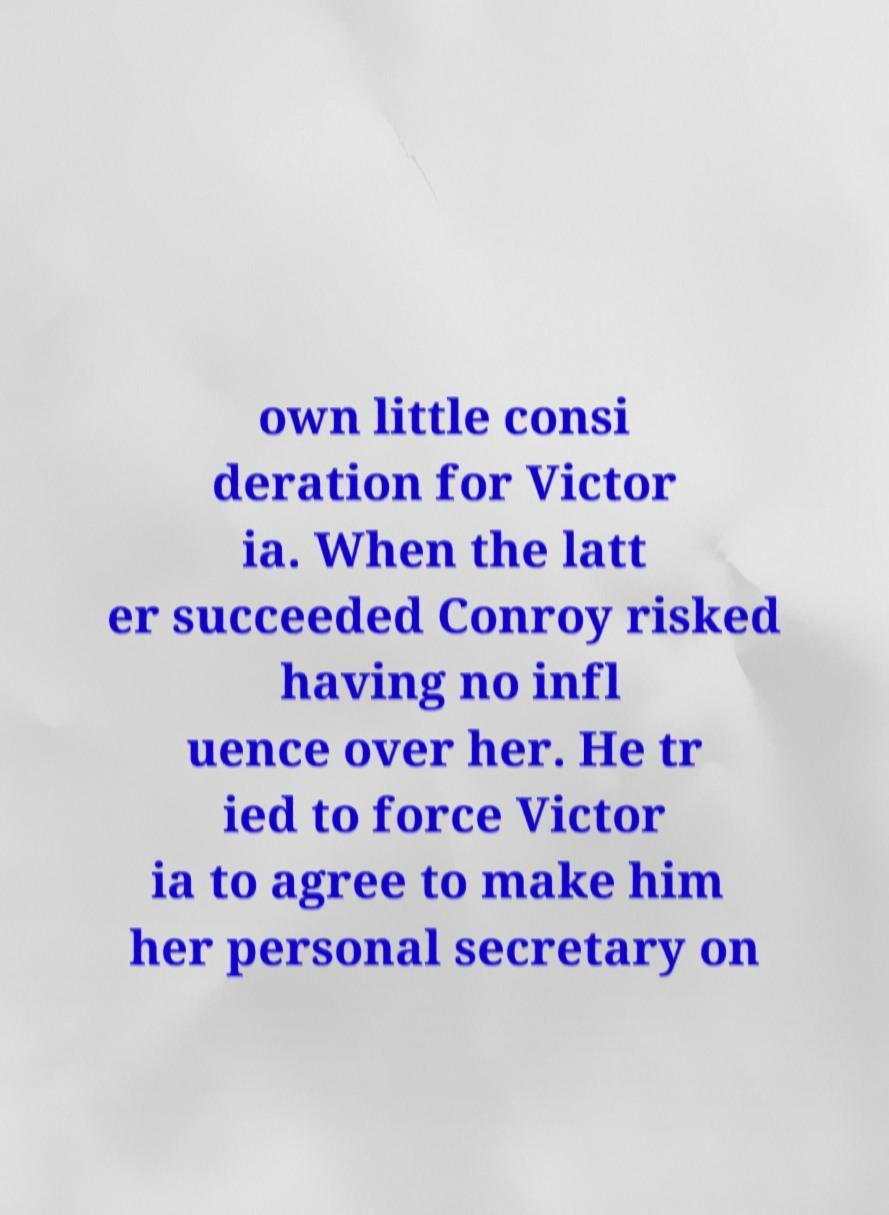Can you read and provide the text displayed in the image?This photo seems to have some interesting text. Can you extract and type it out for me? own little consi deration for Victor ia. When the latt er succeeded Conroy risked having no infl uence over her. He tr ied to force Victor ia to agree to make him her personal secretary on 